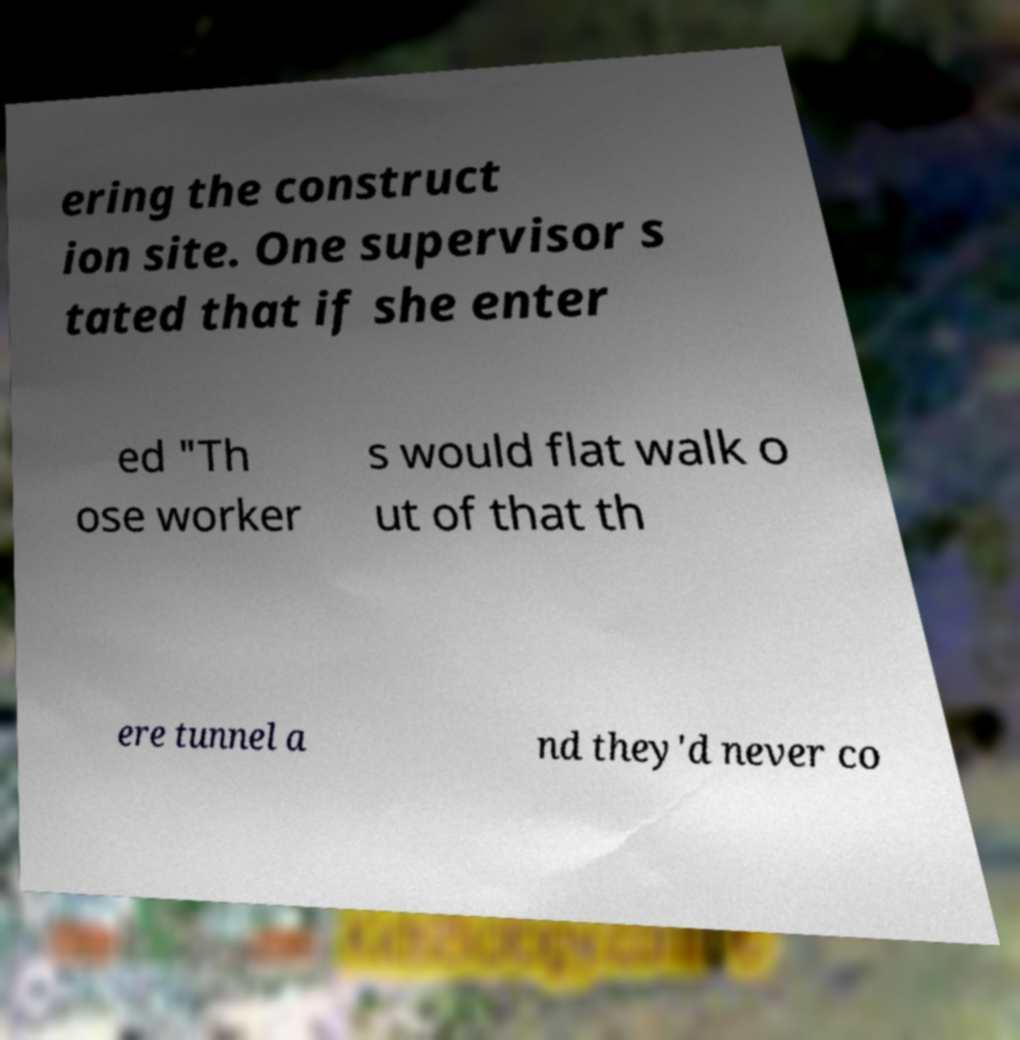Could you extract and type out the text from this image? ering the construct ion site. One supervisor s tated that if she enter ed "Th ose worker s would flat walk o ut of that th ere tunnel a nd they'd never co 